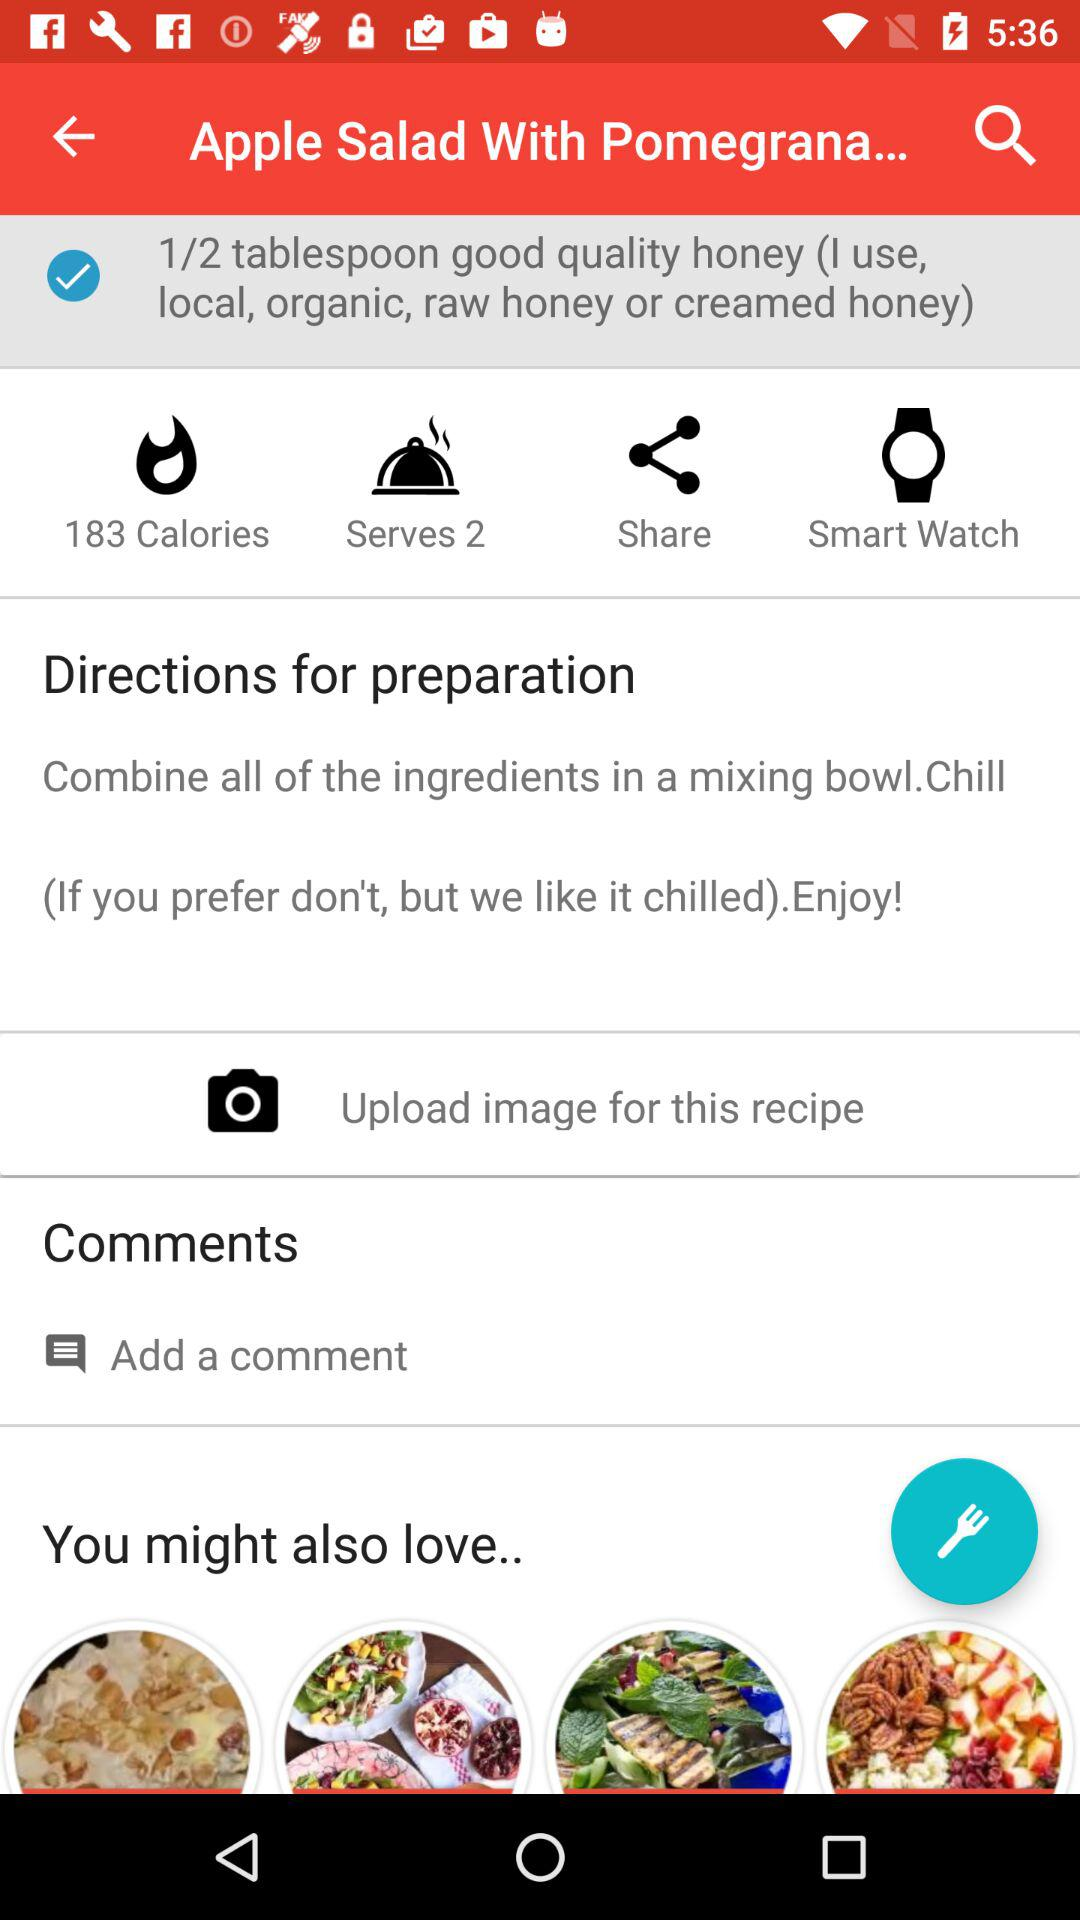What is the total number of calories? The total number of calories is 183. 